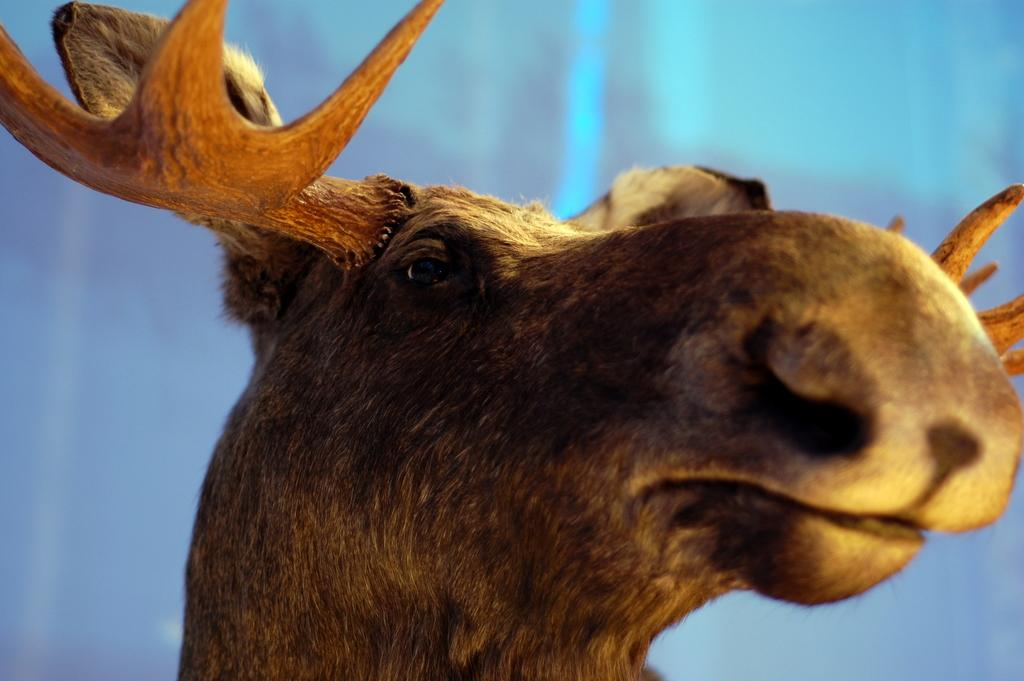What is the main subject of the image? The main subject of the image is a reindeer's face. Where is the reindeer's face located in the image? The reindeer's face is in the middle of the image. What can be seen in the background of the image? There is a wall in the background of the image. Who is the expert in the image? There is no expert present in the image; it features a reindeer's face. What type of pets are visible in the image? There are no pets visible in the image; it features a reindeer's face. 